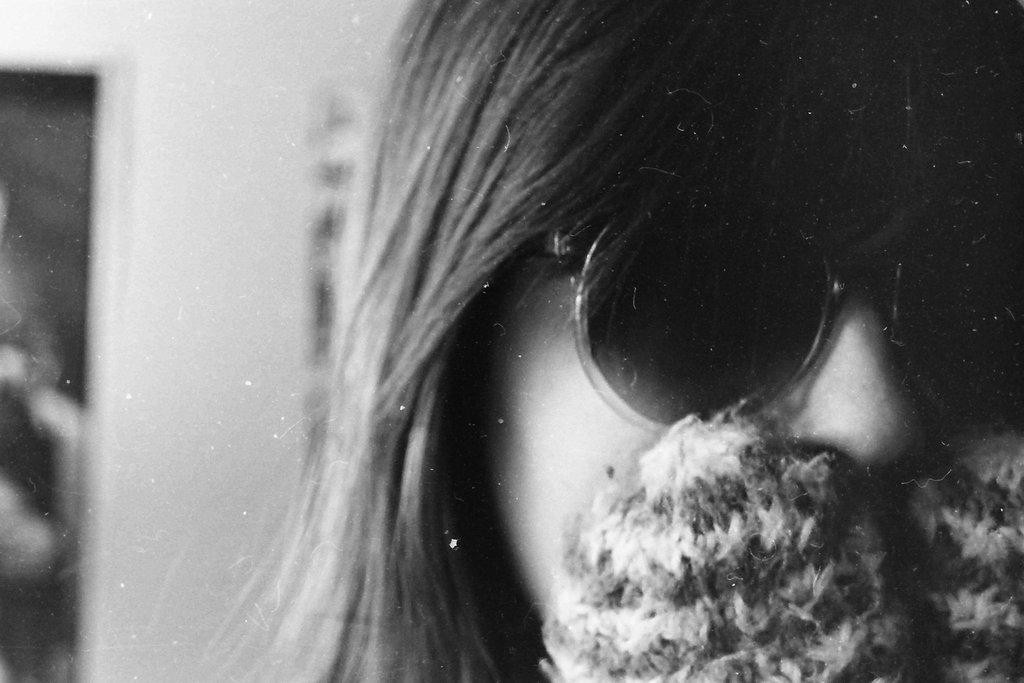What is the main subject of the image? There is a person in the image. What is the person wearing on their face? The person is wearing goggles. What color are the goggles? The goggles are black in color. What can be seen in the background of the image? There is a wall and other objects visible in the background of the image. How is the person attempting to defuse the bomb in the image? There is no bomb present in the image; the person is wearing goggles. What type of glue is the person using to attach the arm to the wall in the image? There is no arm or glue present in the image; the person is wearing goggles and there is a wall in the background. 